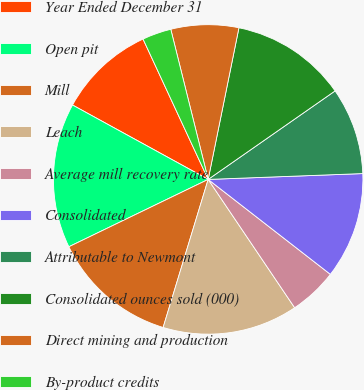Convert chart. <chart><loc_0><loc_0><loc_500><loc_500><pie_chart><fcel>Year Ended December 31<fcel>Open pit<fcel>Mill<fcel>Leach<fcel>Average mill recovery rate<fcel>Consolidated<fcel>Attributable to Newmont<fcel>Consolidated ounces sold (000)<fcel>Direct mining and production<fcel>By-product credits<nl><fcel>10.1%<fcel>15.15%<fcel>13.13%<fcel>14.14%<fcel>5.05%<fcel>11.11%<fcel>9.09%<fcel>12.12%<fcel>7.07%<fcel>3.03%<nl></chart> 